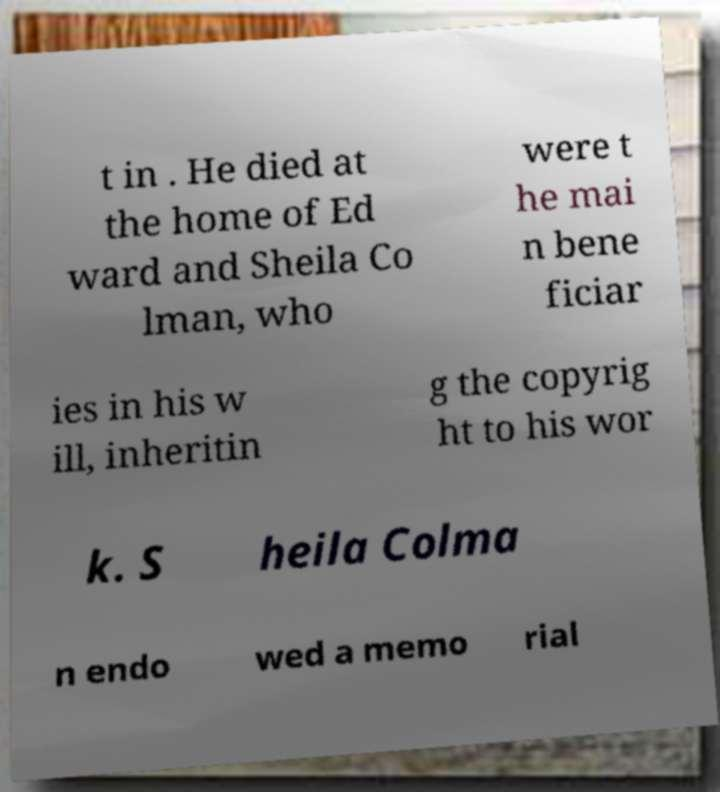Can you read and provide the text displayed in the image?This photo seems to have some interesting text. Can you extract and type it out for me? t in . He died at the home of Ed ward and Sheila Co lman, who were t he mai n bene ficiar ies in his w ill, inheritin g the copyrig ht to his wor k. S heila Colma n endo wed a memo rial 